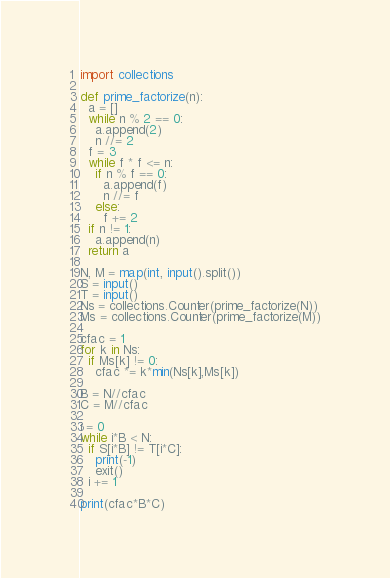Convert code to text. <code><loc_0><loc_0><loc_500><loc_500><_Python_>import collections

def prime_factorize(n):
  a = []
  while n % 2 == 0:
    a.append(2)
    n //= 2
  f = 3
  while f * f <= n:
    if n % f == 0:
      a.append(f)
      n //= f
    else:
      f += 2
  if n != 1:
    a.append(n)
  return a

N, M = map(int, input().split())
S = input()
T = input()
Ns = collections.Counter(prime_factorize(N))
Ms = collections.Counter(prime_factorize(M))

cfac = 1
for k in Ns:
  if Ms[k] != 0:
    cfac *= k*min(Ns[k],Ms[k])
  
B = N//cfac
C = M//cfac

i = 0
while i*B < N:
  if S[i*B] != T[i*C]:
    print(-1)
    exit()
  i += 1

print(cfac*B*C)</code> 